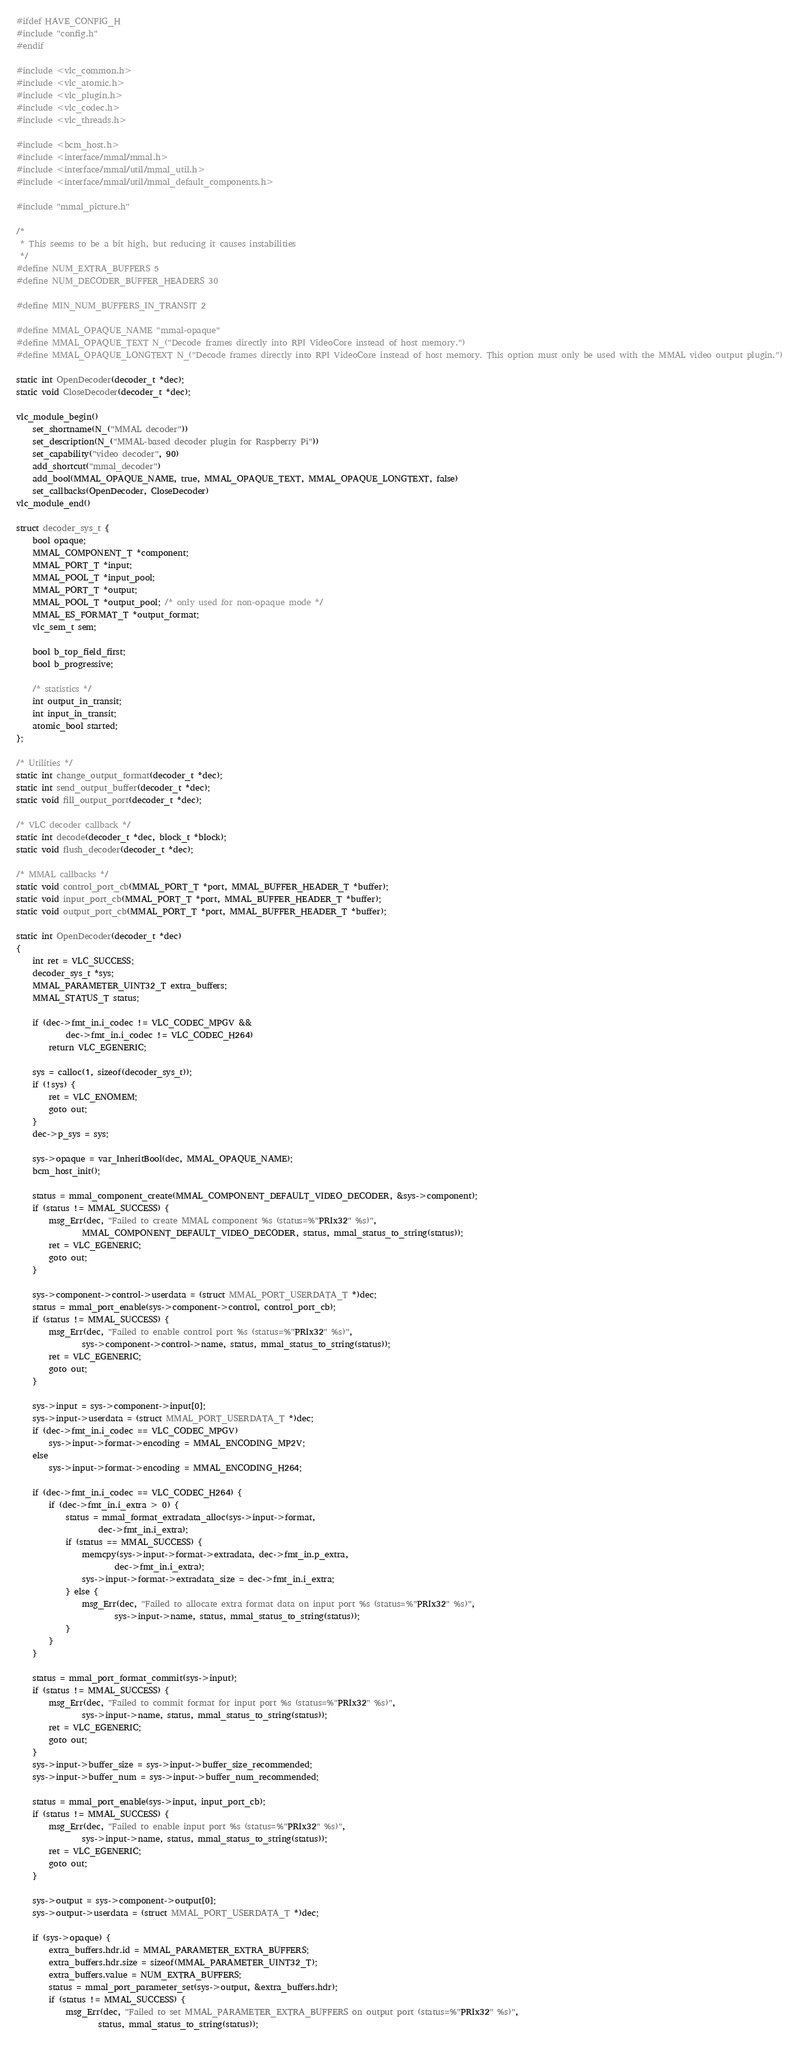<code> <loc_0><loc_0><loc_500><loc_500><_C_>
#ifdef HAVE_CONFIG_H
#include "config.h"
#endif

#include <vlc_common.h>
#include <vlc_atomic.h>
#include <vlc_plugin.h>
#include <vlc_codec.h>
#include <vlc_threads.h>

#include <bcm_host.h>
#include <interface/mmal/mmal.h>
#include <interface/mmal/util/mmal_util.h>
#include <interface/mmal/util/mmal_default_components.h>

#include "mmal_picture.h"

/*
 * This seems to be a bit high, but reducing it causes instabilities
 */
#define NUM_EXTRA_BUFFERS 5
#define NUM_DECODER_BUFFER_HEADERS 30

#define MIN_NUM_BUFFERS_IN_TRANSIT 2

#define MMAL_OPAQUE_NAME "mmal-opaque"
#define MMAL_OPAQUE_TEXT N_("Decode frames directly into RPI VideoCore instead of host memory.")
#define MMAL_OPAQUE_LONGTEXT N_("Decode frames directly into RPI VideoCore instead of host memory. This option must only be used with the MMAL video output plugin.")

static int OpenDecoder(decoder_t *dec);
static void CloseDecoder(decoder_t *dec);

vlc_module_begin()
    set_shortname(N_("MMAL decoder"))
    set_description(N_("MMAL-based decoder plugin for Raspberry Pi"))
    set_capability("video decoder", 90)
    add_shortcut("mmal_decoder")
    add_bool(MMAL_OPAQUE_NAME, true, MMAL_OPAQUE_TEXT, MMAL_OPAQUE_LONGTEXT, false)
    set_callbacks(OpenDecoder, CloseDecoder)
vlc_module_end()

struct decoder_sys_t {
    bool opaque;
    MMAL_COMPONENT_T *component;
    MMAL_PORT_T *input;
    MMAL_POOL_T *input_pool;
    MMAL_PORT_T *output;
    MMAL_POOL_T *output_pool; /* only used for non-opaque mode */
    MMAL_ES_FORMAT_T *output_format;
    vlc_sem_t sem;

    bool b_top_field_first;
    bool b_progressive;

    /* statistics */
    int output_in_transit;
    int input_in_transit;
    atomic_bool started;
};

/* Utilities */
static int change_output_format(decoder_t *dec);
static int send_output_buffer(decoder_t *dec);
static void fill_output_port(decoder_t *dec);

/* VLC decoder callback */
static int decode(decoder_t *dec, block_t *block);
static void flush_decoder(decoder_t *dec);

/* MMAL callbacks */
static void control_port_cb(MMAL_PORT_T *port, MMAL_BUFFER_HEADER_T *buffer);
static void input_port_cb(MMAL_PORT_T *port, MMAL_BUFFER_HEADER_T *buffer);
static void output_port_cb(MMAL_PORT_T *port, MMAL_BUFFER_HEADER_T *buffer);

static int OpenDecoder(decoder_t *dec)
{
    int ret = VLC_SUCCESS;
    decoder_sys_t *sys;
    MMAL_PARAMETER_UINT32_T extra_buffers;
    MMAL_STATUS_T status;

    if (dec->fmt_in.i_codec != VLC_CODEC_MPGV &&
            dec->fmt_in.i_codec != VLC_CODEC_H264)
        return VLC_EGENERIC;

    sys = calloc(1, sizeof(decoder_sys_t));
    if (!sys) {
        ret = VLC_ENOMEM;
        goto out;
    }
    dec->p_sys = sys;

    sys->opaque = var_InheritBool(dec, MMAL_OPAQUE_NAME);
    bcm_host_init();

    status = mmal_component_create(MMAL_COMPONENT_DEFAULT_VIDEO_DECODER, &sys->component);
    if (status != MMAL_SUCCESS) {
        msg_Err(dec, "Failed to create MMAL component %s (status=%"PRIx32" %s)",
                MMAL_COMPONENT_DEFAULT_VIDEO_DECODER, status, mmal_status_to_string(status));
        ret = VLC_EGENERIC;
        goto out;
    }

    sys->component->control->userdata = (struct MMAL_PORT_USERDATA_T *)dec;
    status = mmal_port_enable(sys->component->control, control_port_cb);
    if (status != MMAL_SUCCESS) {
        msg_Err(dec, "Failed to enable control port %s (status=%"PRIx32" %s)",
                sys->component->control->name, status, mmal_status_to_string(status));
        ret = VLC_EGENERIC;
        goto out;
    }

    sys->input = sys->component->input[0];
    sys->input->userdata = (struct MMAL_PORT_USERDATA_T *)dec;
    if (dec->fmt_in.i_codec == VLC_CODEC_MPGV)
        sys->input->format->encoding = MMAL_ENCODING_MP2V;
    else
        sys->input->format->encoding = MMAL_ENCODING_H264;

    if (dec->fmt_in.i_codec == VLC_CODEC_H264) {
        if (dec->fmt_in.i_extra > 0) {
            status = mmal_format_extradata_alloc(sys->input->format,
                    dec->fmt_in.i_extra);
            if (status == MMAL_SUCCESS) {
                memcpy(sys->input->format->extradata, dec->fmt_in.p_extra,
                        dec->fmt_in.i_extra);
                sys->input->format->extradata_size = dec->fmt_in.i_extra;
            } else {
                msg_Err(dec, "Failed to allocate extra format data on input port %s (status=%"PRIx32" %s)",
                        sys->input->name, status, mmal_status_to_string(status));
            }
        }
    }

    status = mmal_port_format_commit(sys->input);
    if (status != MMAL_SUCCESS) {
        msg_Err(dec, "Failed to commit format for input port %s (status=%"PRIx32" %s)",
                sys->input->name, status, mmal_status_to_string(status));
        ret = VLC_EGENERIC;
        goto out;
    }
    sys->input->buffer_size = sys->input->buffer_size_recommended;
    sys->input->buffer_num = sys->input->buffer_num_recommended;

    status = mmal_port_enable(sys->input, input_port_cb);
    if (status != MMAL_SUCCESS) {
        msg_Err(dec, "Failed to enable input port %s (status=%"PRIx32" %s)",
                sys->input->name, status, mmal_status_to_string(status));
        ret = VLC_EGENERIC;
        goto out;
    }

    sys->output = sys->component->output[0];
    sys->output->userdata = (struct MMAL_PORT_USERDATA_T *)dec;

    if (sys->opaque) {
        extra_buffers.hdr.id = MMAL_PARAMETER_EXTRA_BUFFERS;
        extra_buffers.hdr.size = sizeof(MMAL_PARAMETER_UINT32_T);
        extra_buffers.value = NUM_EXTRA_BUFFERS;
        status = mmal_port_parameter_set(sys->output, &extra_buffers.hdr);
        if (status != MMAL_SUCCESS) {
            msg_Err(dec, "Failed to set MMAL_PARAMETER_EXTRA_BUFFERS on output port (status=%"PRIx32" %s)",
                    status, mmal_status_to_string(status));</code> 